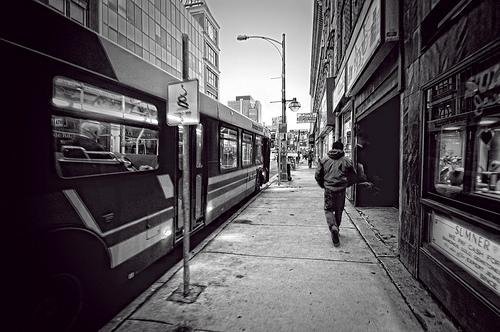Question: what color is the man's hat?
Choices:
A. Blue.
B. Grey.
C. Black.
D. Red.
Answer with the letter. Answer: C Question: why is the man on the street?
Choices:
A. Cleaning it.
B. Walking.
C. Sleeping.
D. Crossing guard.
Answer with the letter. Answer: B Question: what color is the sign?
Choices:
A. White.
B. Red.
C. Yellow.
D. Green.
Answer with the letter. Answer: A Question: where was the photo taken?
Choices:
A. On a boat.
B. Downtown.
C. At the zoo.
D. In the car.
Answer with the letter. Answer: B Question: how many people are there?
Choices:
A. Two.
B. One.
C. Three.
D. Zero.
Answer with the letter. Answer: B Question: who is walking?
Choices:
A. The woman.
B. Two boys.
C. The man.
D. A horse.
Answer with the letter. Answer: C 